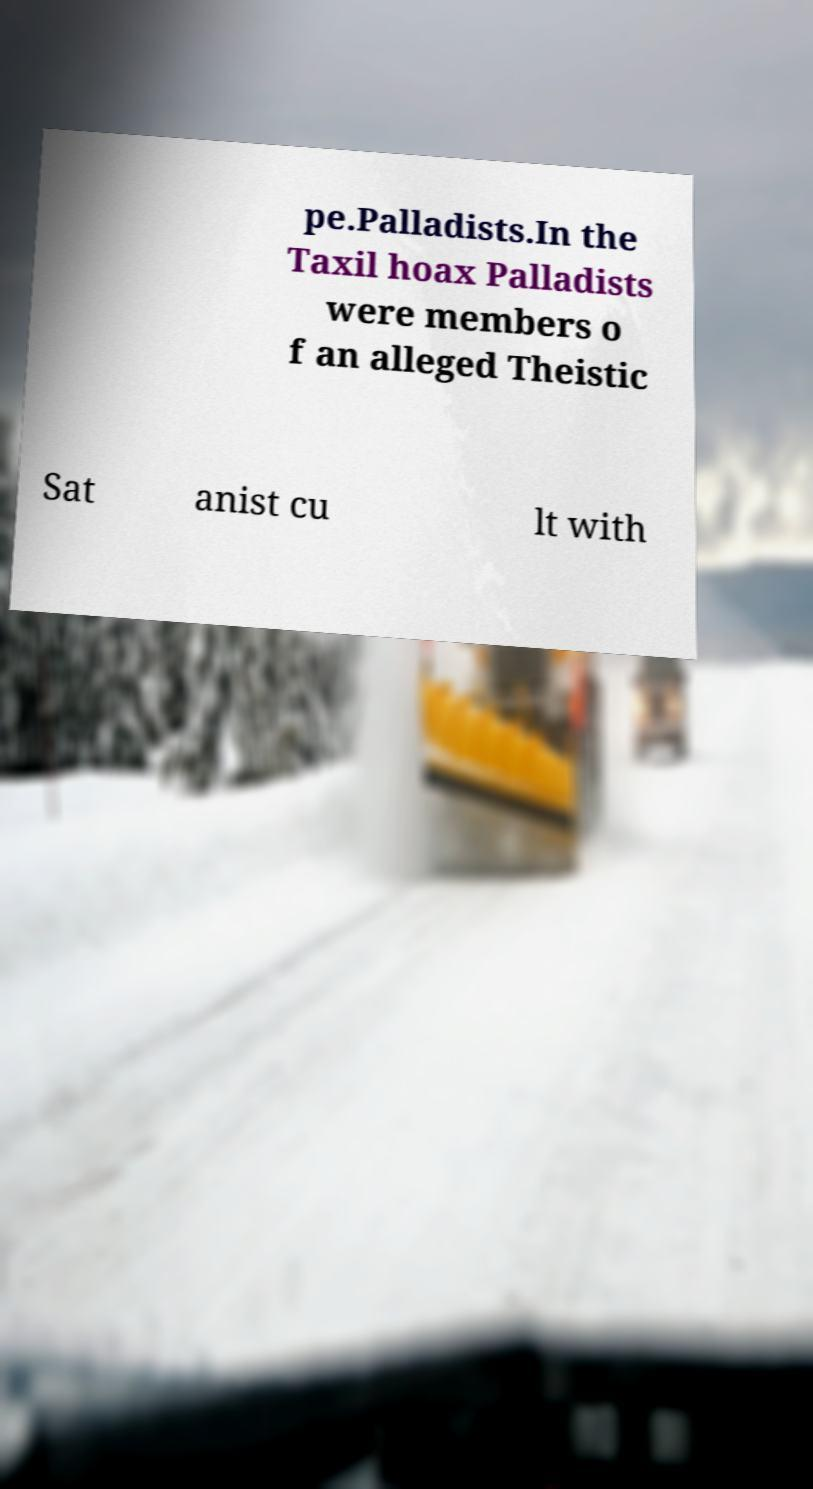Please identify and transcribe the text found in this image. pe.Palladists.In the Taxil hoax Palladists were members o f an alleged Theistic Sat anist cu lt with 